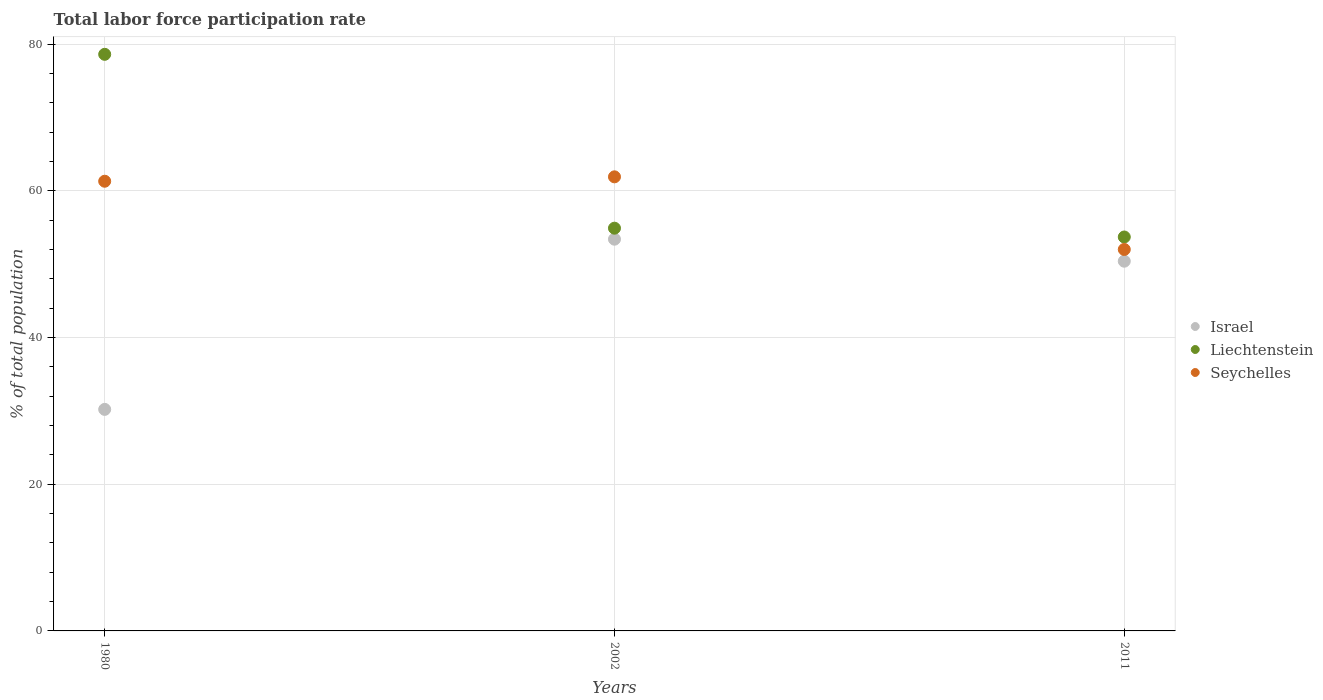How many different coloured dotlines are there?
Provide a succinct answer. 3. Is the number of dotlines equal to the number of legend labels?
Make the answer very short. Yes. What is the total labor force participation rate in Seychelles in 1980?
Provide a succinct answer. 61.3. Across all years, what is the maximum total labor force participation rate in Seychelles?
Provide a succinct answer. 61.9. Across all years, what is the minimum total labor force participation rate in Israel?
Your answer should be compact. 30.2. What is the total total labor force participation rate in Israel in the graph?
Give a very brief answer. 134. What is the difference between the total labor force participation rate in Israel in 1980 and that in 2002?
Offer a terse response. -23.2. What is the difference between the total labor force participation rate in Israel in 2011 and the total labor force participation rate in Seychelles in 1980?
Your answer should be compact. -10.9. What is the average total labor force participation rate in Seychelles per year?
Give a very brief answer. 58.4. In the year 2011, what is the difference between the total labor force participation rate in Israel and total labor force participation rate in Liechtenstein?
Provide a short and direct response. -3.3. In how many years, is the total labor force participation rate in Seychelles greater than 64 %?
Your answer should be compact. 0. What is the ratio of the total labor force participation rate in Liechtenstein in 1980 to that in 2011?
Keep it short and to the point. 1.46. What is the difference between the highest and the second highest total labor force participation rate in Liechtenstein?
Offer a very short reply. 23.7. What is the difference between the highest and the lowest total labor force participation rate in Israel?
Offer a very short reply. 23.2. In how many years, is the total labor force participation rate in Seychelles greater than the average total labor force participation rate in Seychelles taken over all years?
Your answer should be very brief. 2. Does the total labor force participation rate in Liechtenstein monotonically increase over the years?
Provide a short and direct response. No. Is the total labor force participation rate in Liechtenstein strictly less than the total labor force participation rate in Seychelles over the years?
Your answer should be compact. No. How many dotlines are there?
Provide a succinct answer. 3. What is the difference between two consecutive major ticks on the Y-axis?
Make the answer very short. 20. Are the values on the major ticks of Y-axis written in scientific E-notation?
Give a very brief answer. No. Does the graph contain any zero values?
Your answer should be very brief. No. How many legend labels are there?
Give a very brief answer. 3. How are the legend labels stacked?
Give a very brief answer. Vertical. What is the title of the graph?
Give a very brief answer. Total labor force participation rate. What is the label or title of the Y-axis?
Provide a short and direct response. % of total population. What is the % of total population of Israel in 1980?
Make the answer very short. 30.2. What is the % of total population in Liechtenstein in 1980?
Your response must be concise. 78.6. What is the % of total population in Seychelles in 1980?
Offer a very short reply. 61.3. What is the % of total population in Israel in 2002?
Provide a succinct answer. 53.4. What is the % of total population of Liechtenstein in 2002?
Keep it short and to the point. 54.9. What is the % of total population of Seychelles in 2002?
Give a very brief answer. 61.9. What is the % of total population in Israel in 2011?
Provide a succinct answer. 50.4. What is the % of total population of Liechtenstein in 2011?
Ensure brevity in your answer.  53.7. Across all years, what is the maximum % of total population of Israel?
Your answer should be compact. 53.4. Across all years, what is the maximum % of total population of Liechtenstein?
Offer a terse response. 78.6. Across all years, what is the maximum % of total population of Seychelles?
Your answer should be compact. 61.9. Across all years, what is the minimum % of total population of Israel?
Your answer should be compact. 30.2. Across all years, what is the minimum % of total population in Liechtenstein?
Your answer should be very brief. 53.7. Across all years, what is the minimum % of total population of Seychelles?
Make the answer very short. 52. What is the total % of total population in Israel in the graph?
Ensure brevity in your answer.  134. What is the total % of total population in Liechtenstein in the graph?
Offer a very short reply. 187.2. What is the total % of total population of Seychelles in the graph?
Your response must be concise. 175.2. What is the difference between the % of total population in Israel in 1980 and that in 2002?
Offer a terse response. -23.2. What is the difference between the % of total population of Liechtenstein in 1980 and that in 2002?
Keep it short and to the point. 23.7. What is the difference between the % of total population in Israel in 1980 and that in 2011?
Ensure brevity in your answer.  -20.2. What is the difference between the % of total population of Liechtenstein in 1980 and that in 2011?
Keep it short and to the point. 24.9. What is the difference between the % of total population in Israel in 2002 and that in 2011?
Provide a short and direct response. 3. What is the difference between the % of total population of Israel in 1980 and the % of total population of Liechtenstein in 2002?
Make the answer very short. -24.7. What is the difference between the % of total population of Israel in 1980 and the % of total population of Seychelles in 2002?
Make the answer very short. -31.7. What is the difference between the % of total population of Israel in 1980 and the % of total population of Liechtenstein in 2011?
Provide a short and direct response. -23.5. What is the difference between the % of total population in Israel in 1980 and the % of total population in Seychelles in 2011?
Give a very brief answer. -21.8. What is the difference between the % of total population in Liechtenstein in 1980 and the % of total population in Seychelles in 2011?
Your answer should be compact. 26.6. What is the difference between the % of total population in Israel in 2002 and the % of total population in Liechtenstein in 2011?
Your answer should be very brief. -0.3. What is the average % of total population of Israel per year?
Provide a short and direct response. 44.67. What is the average % of total population in Liechtenstein per year?
Provide a succinct answer. 62.4. What is the average % of total population of Seychelles per year?
Provide a succinct answer. 58.4. In the year 1980, what is the difference between the % of total population in Israel and % of total population in Liechtenstein?
Provide a succinct answer. -48.4. In the year 1980, what is the difference between the % of total population in Israel and % of total population in Seychelles?
Offer a terse response. -31.1. In the year 1980, what is the difference between the % of total population in Liechtenstein and % of total population in Seychelles?
Give a very brief answer. 17.3. In the year 2002, what is the difference between the % of total population in Israel and % of total population in Liechtenstein?
Ensure brevity in your answer.  -1.5. In the year 2002, what is the difference between the % of total population in Israel and % of total population in Seychelles?
Offer a terse response. -8.5. In the year 2002, what is the difference between the % of total population in Liechtenstein and % of total population in Seychelles?
Provide a succinct answer. -7. In the year 2011, what is the difference between the % of total population of Israel and % of total population of Liechtenstein?
Keep it short and to the point. -3.3. In the year 2011, what is the difference between the % of total population of Israel and % of total population of Seychelles?
Your response must be concise. -1.6. What is the ratio of the % of total population in Israel in 1980 to that in 2002?
Keep it short and to the point. 0.57. What is the ratio of the % of total population in Liechtenstein in 1980 to that in 2002?
Your answer should be compact. 1.43. What is the ratio of the % of total population of Seychelles in 1980 to that in 2002?
Offer a very short reply. 0.99. What is the ratio of the % of total population of Israel in 1980 to that in 2011?
Your answer should be very brief. 0.6. What is the ratio of the % of total population of Liechtenstein in 1980 to that in 2011?
Offer a terse response. 1.46. What is the ratio of the % of total population of Seychelles in 1980 to that in 2011?
Provide a short and direct response. 1.18. What is the ratio of the % of total population of Israel in 2002 to that in 2011?
Your answer should be compact. 1.06. What is the ratio of the % of total population in Liechtenstein in 2002 to that in 2011?
Offer a terse response. 1.02. What is the ratio of the % of total population in Seychelles in 2002 to that in 2011?
Give a very brief answer. 1.19. What is the difference between the highest and the second highest % of total population in Israel?
Offer a very short reply. 3. What is the difference between the highest and the second highest % of total population in Liechtenstein?
Give a very brief answer. 23.7. What is the difference between the highest and the lowest % of total population in Israel?
Make the answer very short. 23.2. What is the difference between the highest and the lowest % of total population in Liechtenstein?
Ensure brevity in your answer.  24.9. What is the difference between the highest and the lowest % of total population of Seychelles?
Provide a succinct answer. 9.9. 